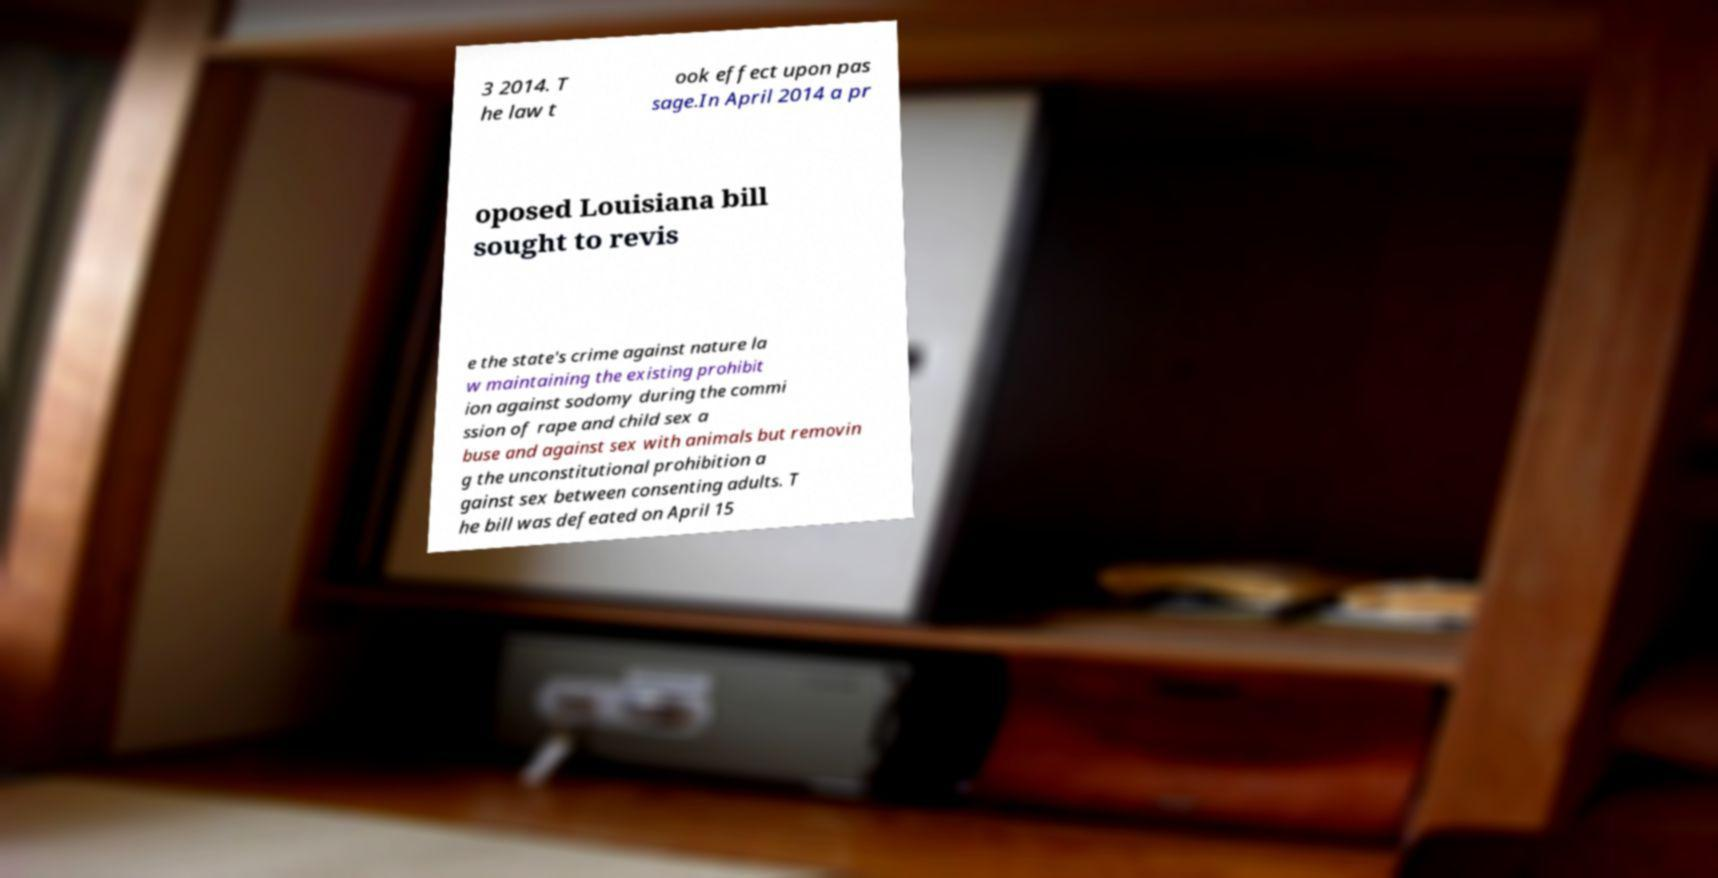Please identify and transcribe the text found in this image. 3 2014. T he law t ook effect upon pas sage.In April 2014 a pr oposed Louisiana bill sought to revis e the state's crime against nature la w maintaining the existing prohibit ion against sodomy during the commi ssion of rape and child sex a buse and against sex with animals but removin g the unconstitutional prohibition a gainst sex between consenting adults. T he bill was defeated on April 15 